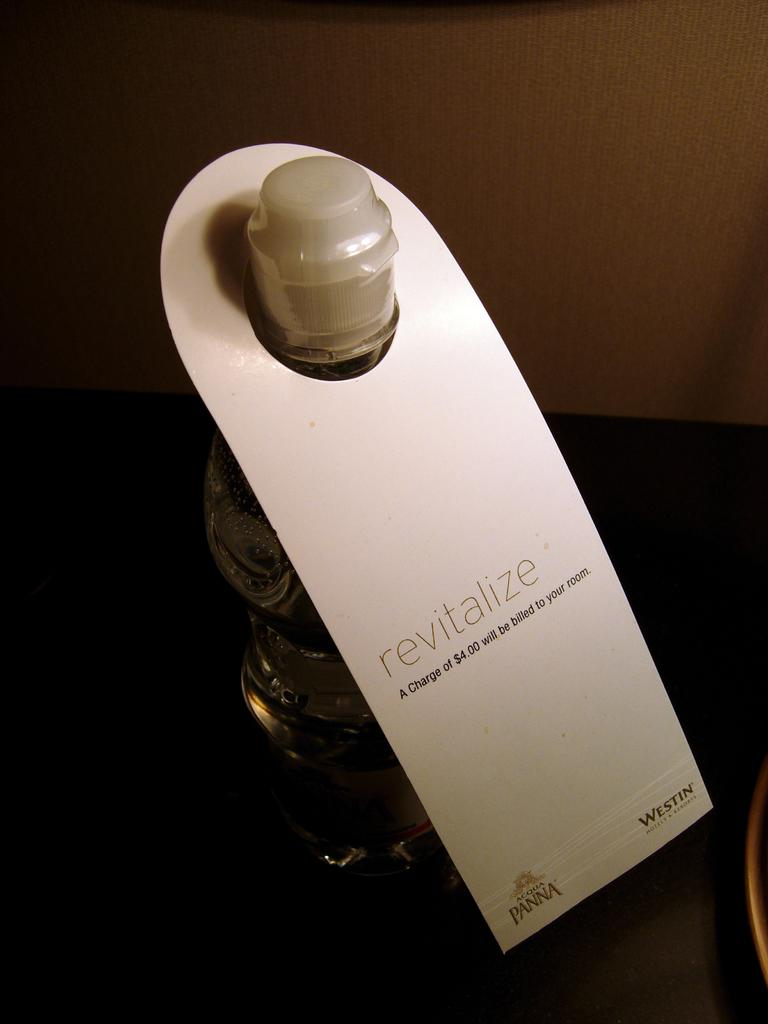Provide a one-sentence caption for the provided image. a bottle of water called revitalize which costs four dollars. 